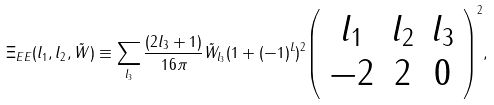Convert formula to latex. <formula><loc_0><loc_0><loc_500><loc_500>\Xi _ { E E } ( l _ { 1 } , l _ { 2 } , \tilde { W } ) \equiv \sum _ { l _ { 3 } } \frac { ( 2 l _ { 3 } + 1 ) } { 1 6 \pi } \tilde { W } _ { l _ { 3 } } ( 1 + ( - 1 ) ^ { L } ) ^ { 2 } { \left ( \begin{array} { c c c } l _ { 1 } & l _ { 2 } & l _ { 3 } \\ - 2 & 2 & 0 \end{array} \right ) ^ { 2 } } ,</formula> 